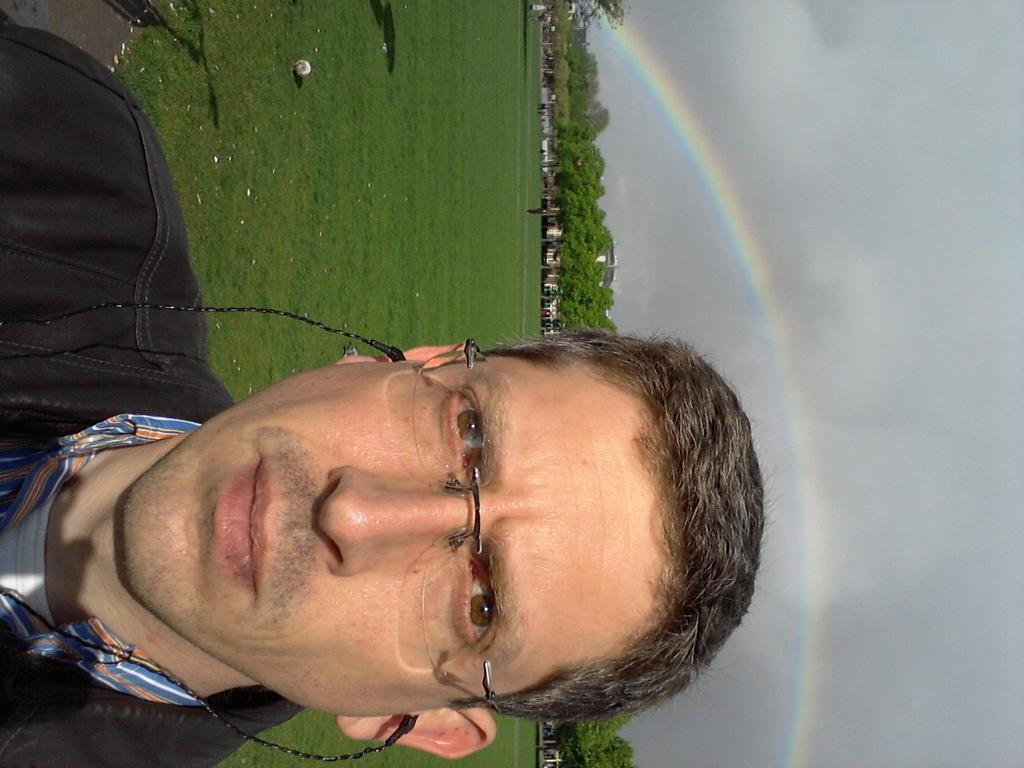In one or two sentences, can you explain what this image depicts? This image is in right direction. On the left side there is a man looking at the picture. On the ground, I can see the grass. In the background there are many houses and trees. On the right side there is a rainbow in the sky. 